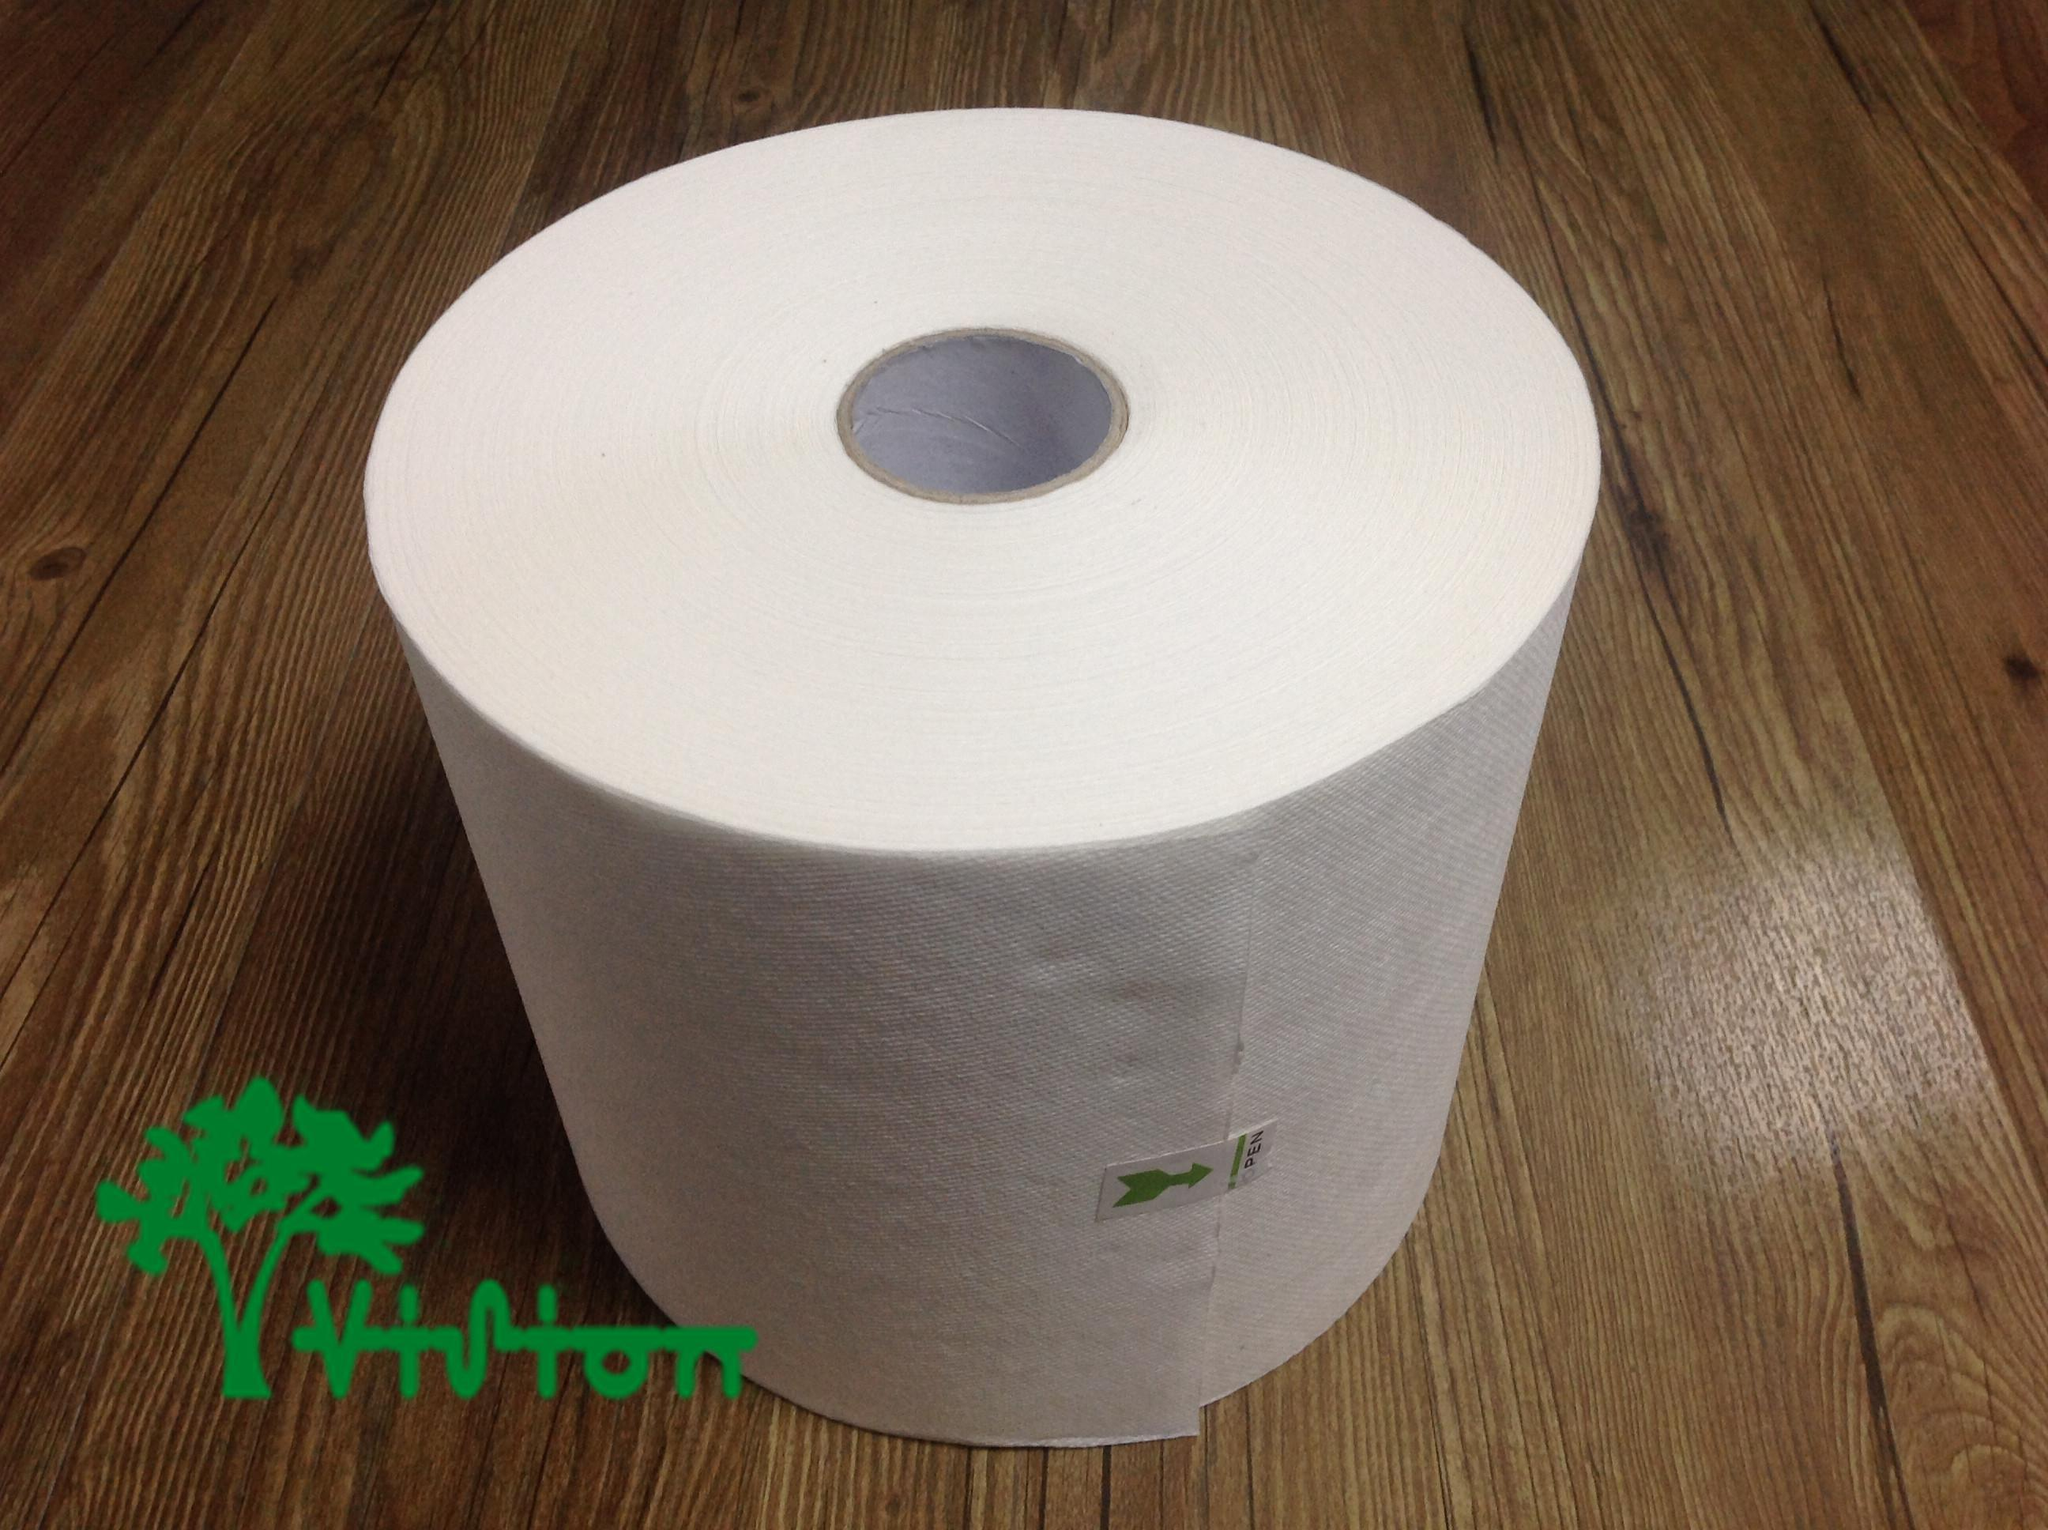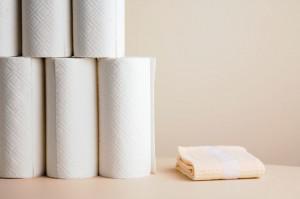The first image is the image on the left, the second image is the image on the right. Considering the images on both sides, is "An image shows a single white roll on a wood surface." valid? Answer yes or no. Yes. 